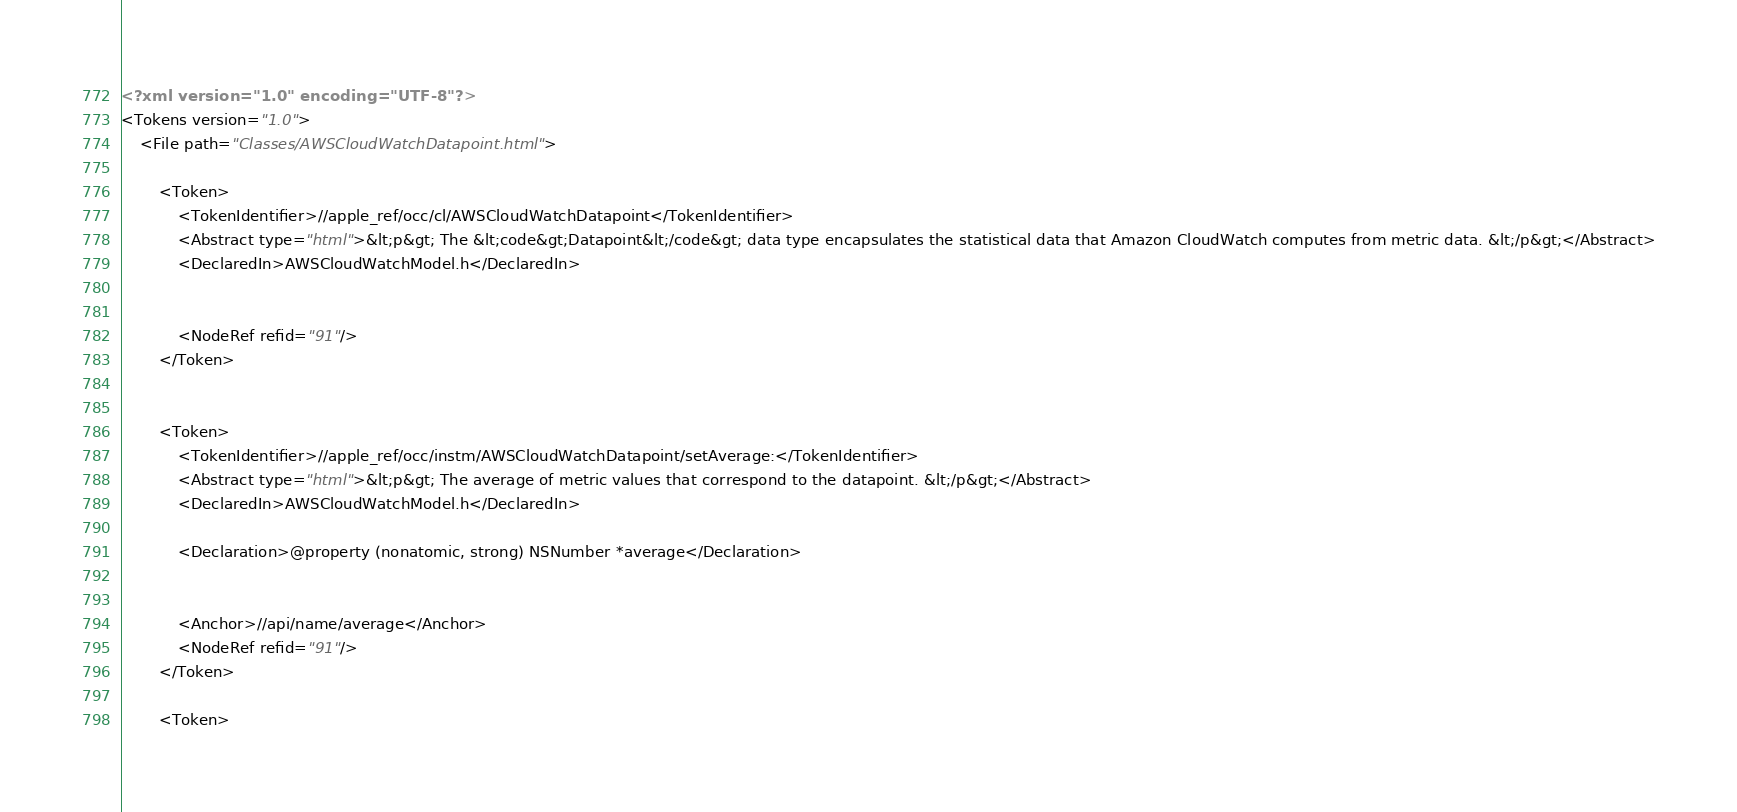Convert code to text. <code><loc_0><loc_0><loc_500><loc_500><_XML_><?xml version="1.0" encoding="UTF-8"?>
<Tokens version="1.0">
	<File path="Classes/AWSCloudWatchDatapoint.html">
		
		<Token>
			<TokenIdentifier>//apple_ref/occ/cl/AWSCloudWatchDatapoint</TokenIdentifier>
			<Abstract type="html">&lt;p&gt; The &lt;code&gt;Datapoint&lt;/code&gt; data type encapsulates the statistical data that Amazon CloudWatch computes from metric data. &lt;/p&gt;</Abstract>
			<DeclaredIn>AWSCloudWatchModel.h</DeclaredIn>
            
			
			<NodeRef refid="91"/>
		</Token>
		
		
		<Token>
			<TokenIdentifier>//apple_ref/occ/instm/AWSCloudWatchDatapoint/setAverage:</TokenIdentifier>
			<Abstract type="html">&lt;p&gt; The average of metric values that correspond to the datapoint. &lt;/p&gt;</Abstract>
			<DeclaredIn>AWSCloudWatchModel.h</DeclaredIn>
			
			<Declaration>@property (nonatomic, strong) NSNumber *average</Declaration>
			
			
			<Anchor>//api/name/average</Anchor>
            <NodeRef refid="91"/>
		</Token>
		
		<Token></code> 